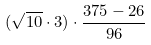<formula> <loc_0><loc_0><loc_500><loc_500>( \sqrt { 1 0 } \cdot 3 ) \cdot \frac { 3 7 5 - 2 6 } { 9 6 }</formula> 